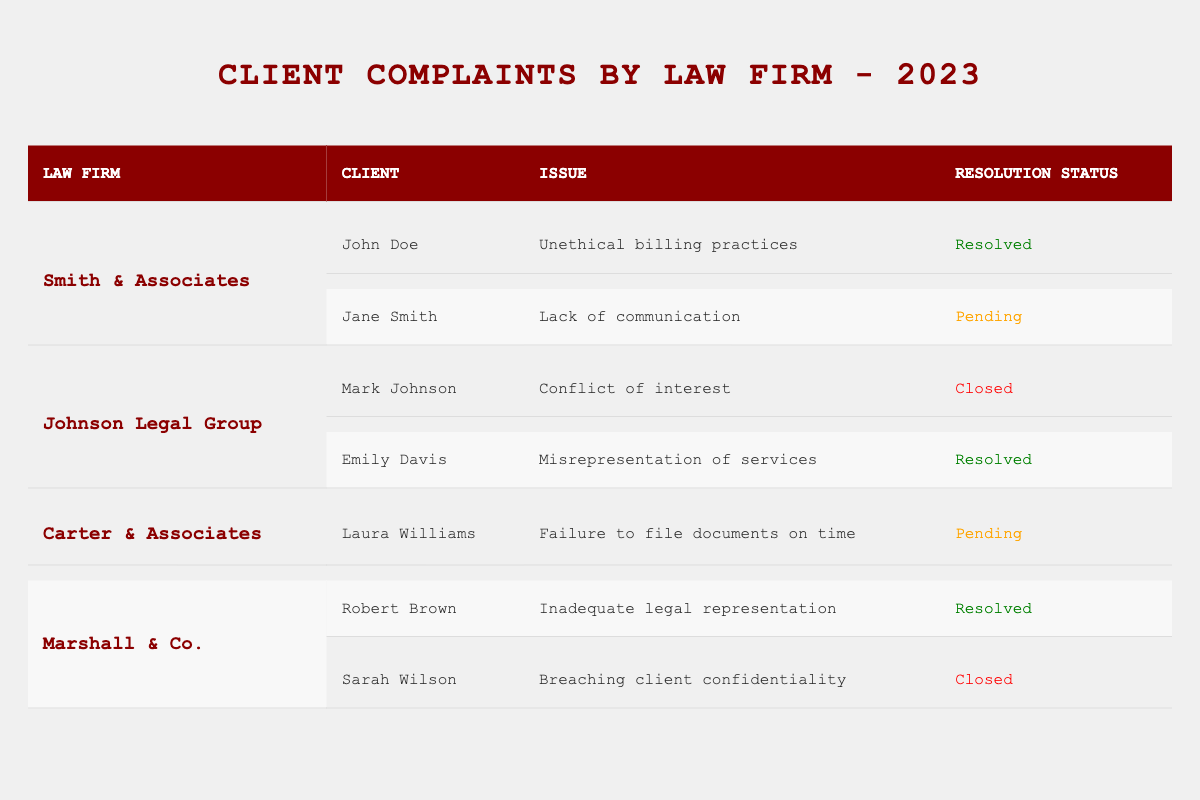What issues did clients of Johnson Legal Group report? The table lists the complaints from clients of Johnson Legal Group: Mark Johnson reported a conflict of interest, and Emily Davis reported misrepresentation of services.
Answer: Conflict of interest, misrepresentation of services How many complaints from Smith & Associates have been resolved? In the table, Smith & Associates has two complaints: one from John Doe (resolved) and one from Jane Smith (pending). Thus, only one is resolved.
Answer: One Is there any complaint from Carter & Associates that is marked as resolved? Referring to the table, there is one complaint from Carter & Associates, which is pending. Therefore, there are no resolved complaints.
Answer: No Which law firm has the most complaints listed in the table? By comparing the number of complaints, Smith & Associates has two, Johnson Legal Group has two, Carter & Associates has one, and Marshall & Co. has two. Thus, Smith & Associates, Johnson Legal Group, and Marshall & Co. are tied for the most complaints with two each.
Answer: Smith & Associates, Johnson Legal Group, Marshall & Co What is the total number of closed cases across all law firms? Examining the table, Johnson Legal Group has one closed complaint (Mark Johnson), and Marshall & Co. has one closed complaint (Sarah Wilson). There are no other closed cases. Adding these, the total number of closed cases is 2.
Answer: Two Are any complaints resolved related to unethical practices? In the table, only one complaint regarding unethical practices is registered: John Doe’s complaint about unethical billing practices is resolved.
Answer: Yes Which client complained about breaching client confidentiality? The table indicates that Sarah Wilson from Marshall & Co. complained about breaching client confidentiality.
Answer: Sarah Wilson How many law firms have a complaint status that is pending? By analyzing the table, Smith & Associates has one pending complaint (Jane Smith) and Carter & Associates also has one pending complaint (Laura Williams), resulting in a total of two law firms with pending complaints.
Answer: Two What is the relationship between the client's issues and their resolution status? Reviewing the table, resolved complaints include unethical billing practices and misrepresentation of services, while pending complaints include lack of communication and failure to file documents on time. Therefore, there is no direct correlation; resolved issues are varied and do not indicate specific patterns.
Answer: No direct correlation 